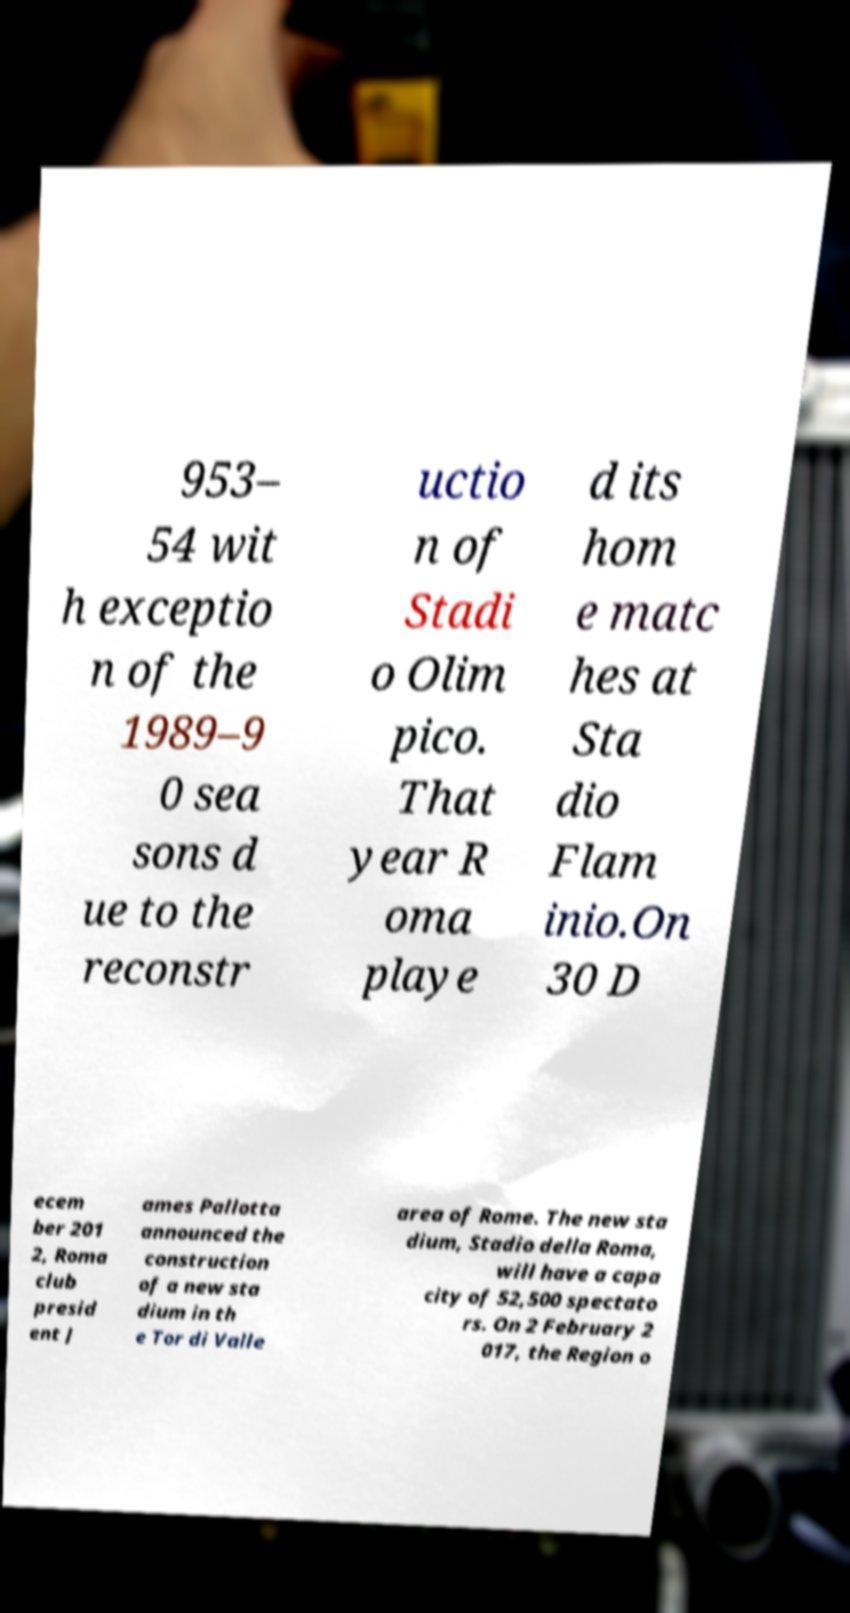For documentation purposes, I need the text within this image transcribed. Could you provide that? 953– 54 wit h exceptio n of the 1989–9 0 sea sons d ue to the reconstr uctio n of Stadi o Olim pico. That year R oma playe d its hom e matc hes at Sta dio Flam inio.On 30 D ecem ber 201 2, Roma club presid ent J ames Pallotta announced the construction of a new sta dium in th e Tor di Valle area of Rome. The new sta dium, Stadio della Roma, will have a capa city of 52,500 spectato rs. On 2 February 2 017, the Region o 